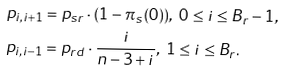<formula> <loc_0><loc_0><loc_500><loc_500>& p _ { i , i + 1 } = p _ { s r } \cdot ( 1 - \pi _ { s } ( 0 ) ) , \ 0 \leq i \leq B _ { r } - 1 , \\ & p _ { i , i - 1 } = p _ { r d } \cdot \frac { i } { n - 3 + i } , \ 1 \leq i \leq B _ { r } .</formula> 